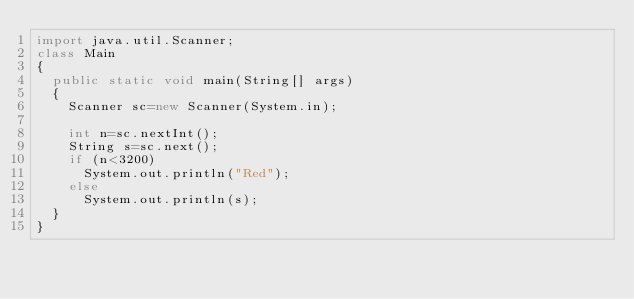<code> <loc_0><loc_0><loc_500><loc_500><_Java_>import java.util.Scanner;
class Main
{
  public static void main(String[] args)
  {
    Scanner sc=new Scanner(System.in);
    
    int n=sc.nextInt();
    String s=sc.next();
    if (n<3200)
      System.out.println("Red");
    else
      System.out.println(s);
  }
}</code> 